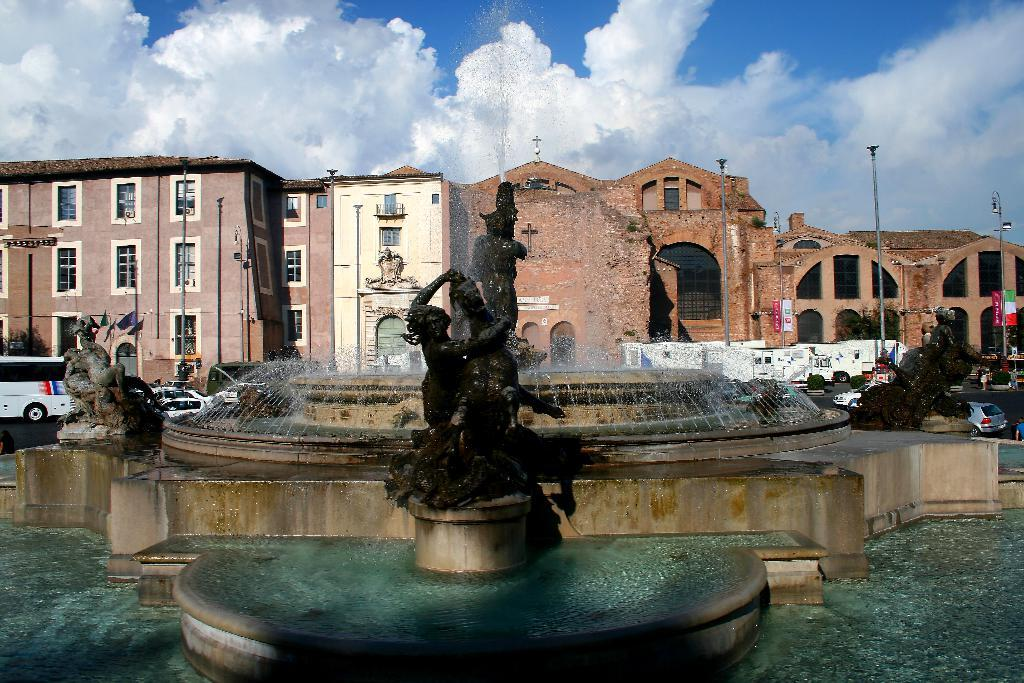What is the main subject of the image? There is a statue in the image. What is unique about the statue? The statue is part of a fountain. What can be seen in the distance behind the statue? There are buildings visible in the background of the image. What type of vehicles are parked on the road in the image? Cars are parked on the road in the image. What advice does the grandmother give to the parent in the image? There is no grandmother or parent present in the image; it features a statue and a fountain. What is the title of the book held by the child in the image? There is no child or book present in the image; it features a statue and a fountain. 